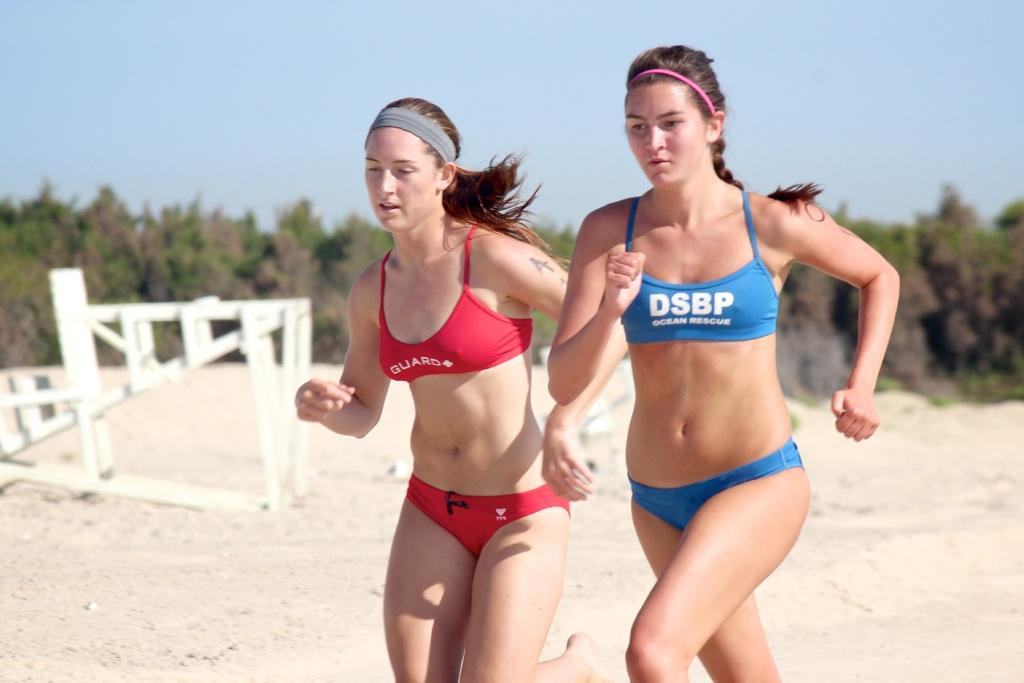Who is present in the image? There are women in the image. What is the surface the women are standing on? The women are on the sand. What can be seen in the background of the image? There are trees, sky, and a sculpture visible in the background of the image. What type of riddle is the sculpture in the image trying to solve? There is no riddle present in the image; it is a sculpture in the background. Can you tell me how much credit the women have earned for their performance in the image? There is no indication of a performance or credit in the image; it simply shows women on the sand with a background of trees, sky, and a sculpture. 